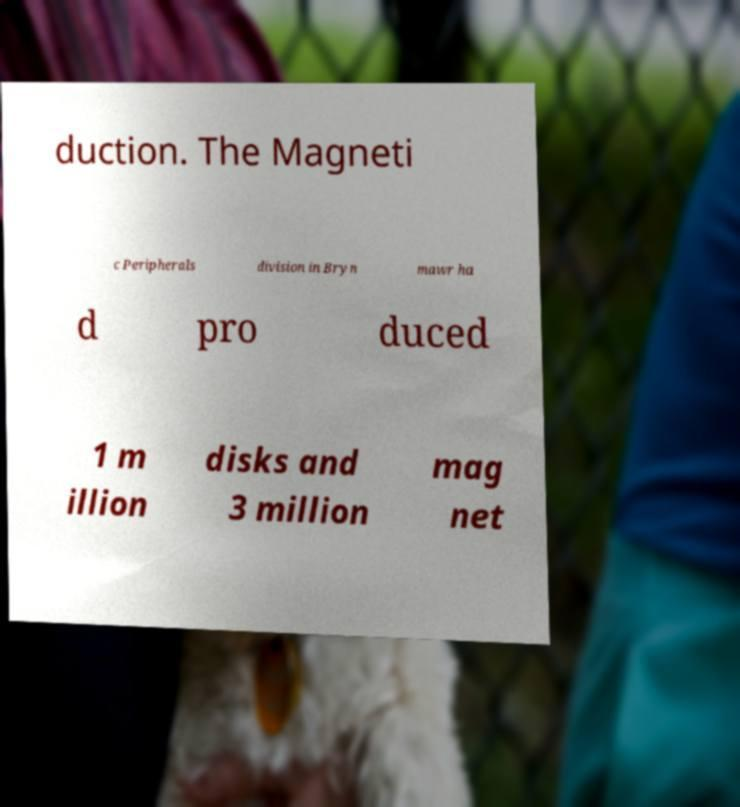Can you read and provide the text displayed in the image?This photo seems to have some interesting text. Can you extract and type it out for me? duction. The Magneti c Peripherals division in Bryn mawr ha d pro duced 1 m illion disks and 3 million mag net 